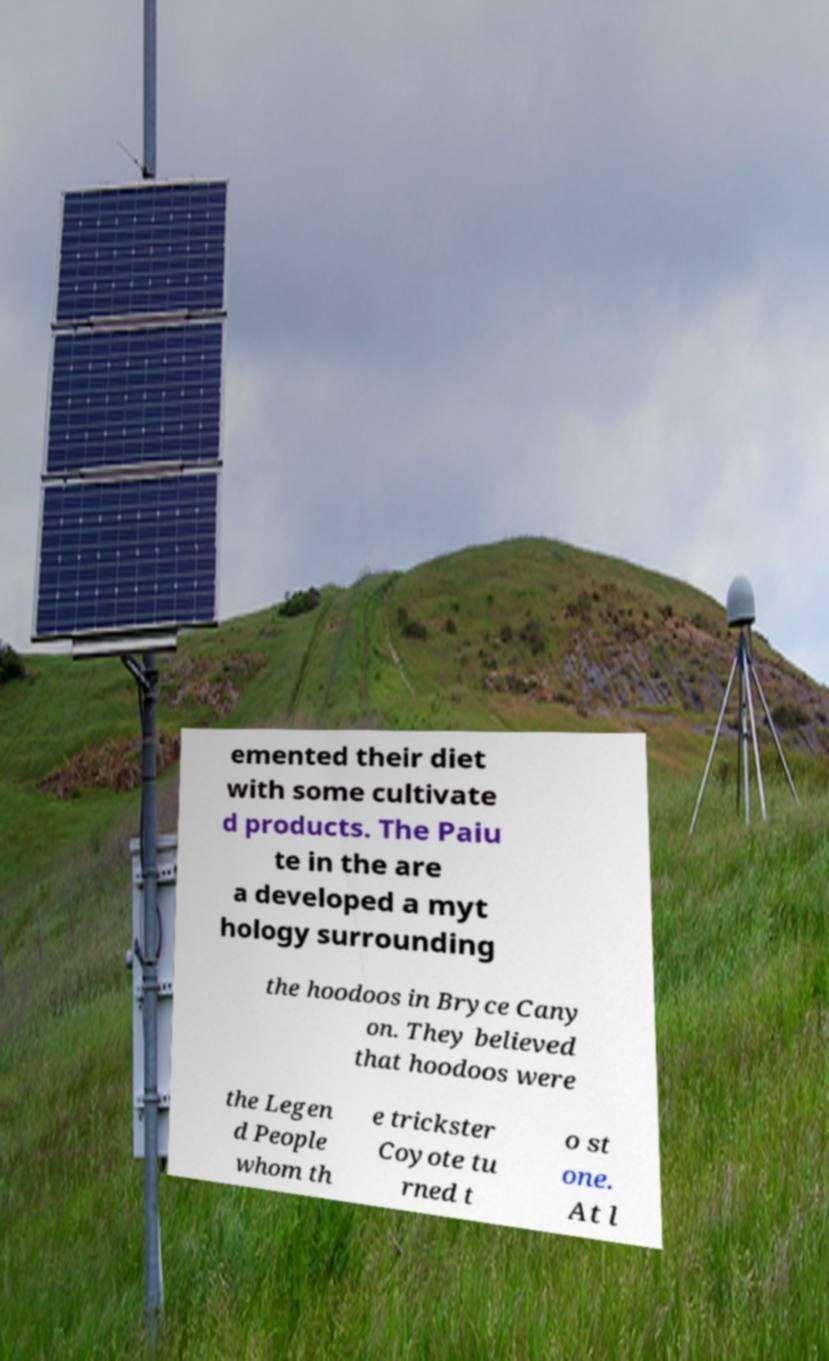I need the written content from this picture converted into text. Can you do that? emented their diet with some cultivate d products. The Paiu te in the are a developed a myt hology surrounding the hoodoos in Bryce Cany on. They believed that hoodoos were the Legen d People whom th e trickster Coyote tu rned t o st one. At l 